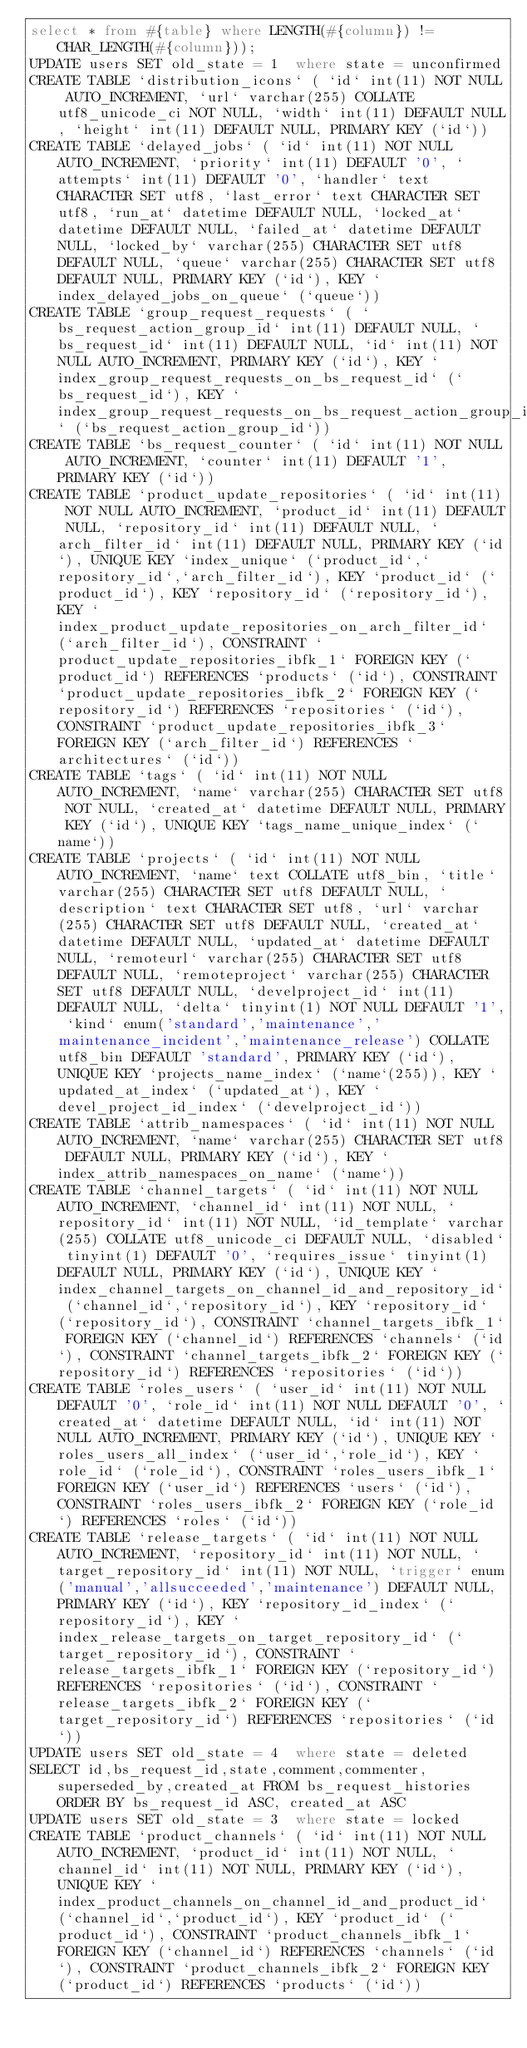Convert code to text. <code><loc_0><loc_0><loc_500><loc_500><_SQL_>select * from #{table} where LENGTH(#{column}) != CHAR_LENGTH(#{column}));
UPDATE users SET old_state = 1  where state = unconfirmed
CREATE TABLE `distribution_icons` ( `id` int(11) NOT NULL AUTO_INCREMENT, `url` varchar(255) COLLATE utf8_unicode_ci NOT NULL, `width` int(11) DEFAULT NULL, `height` int(11) DEFAULT NULL, PRIMARY KEY (`id`))
CREATE TABLE `delayed_jobs` ( `id` int(11) NOT NULL AUTO_INCREMENT, `priority` int(11) DEFAULT '0', `attempts` int(11) DEFAULT '0', `handler` text CHARACTER SET utf8, `last_error` text CHARACTER SET utf8, `run_at` datetime DEFAULT NULL, `locked_at` datetime DEFAULT NULL, `failed_at` datetime DEFAULT NULL, `locked_by` varchar(255) CHARACTER SET utf8 DEFAULT NULL, `queue` varchar(255) CHARACTER SET utf8 DEFAULT NULL, PRIMARY KEY (`id`), KEY `index_delayed_jobs_on_queue` (`queue`))
CREATE TABLE `group_request_requests` ( `bs_request_action_group_id` int(11) DEFAULT NULL, `bs_request_id` int(11) DEFAULT NULL, `id` int(11) NOT NULL AUTO_INCREMENT, PRIMARY KEY (`id`), KEY `index_group_request_requests_on_bs_request_id` (`bs_request_id`), KEY `index_group_request_requests_on_bs_request_action_group_id` (`bs_request_action_group_id`))
CREATE TABLE `bs_request_counter` ( `id` int(11) NOT NULL AUTO_INCREMENT, `counter` int(11) DEFAULT '1', PRIMARY KEY (`id`))
CREATE TABLE `product_update_repositories` ( `id` int(11) NOT NULL AUTO_INCREMENT, `product_id` int(11) DEFAULT NULL, `repository_id` int(11) DEFAULT NULL, `arch_filter_id` int(11) DEFAULT NULL, PRIMARY KEY (`id`), UNIQUE KEY `index_unique` (`product_id`,`repository_id`,`arch_filter_id`), KEY `product_id` (`product_id`), KEY `repository_id` (`repository_id`), KEY `index_product_update_repositories_on_arch_filter_id` (`arch_filter_id`), CONSTRAINT `product_update_repositories_ibfk_1` FOREIGN KEY (`product_id`) REFERENCES `products` (`id`), CONSTRAINT `product_update_repositories_ibfk_2` FOREIGN KEY (`repository_id`) REFERENCES `repositories` (`id`), CONSTRAINT `product_update_repositories_ibfk_3` FOREIGN KEY (`arch_filter_id`) REFERENCES `architectures` (`id`))
CREATE TABLE `tags` ( `id` int(11) NOT NULL AUTO_INCREMENT, `name` varchar(255) CHARACTER SET utf8 NOT NULL, `created_at` datetime DEFAULT NULL, PRIMARY KEY (`id`), UNIQUE KEY `tags_name_unique_index` (`name`))
CREATE TABLE `projects` ( `id` int(11) NOT NULL AUTO_INCREMENT, `name` text COLLATE utf8_bin, `title` varchar(255) CHARACTER SET utf8 DEFAULT NULL, `description` text CHARACTER SET utf8, `url` varchar(255) CHARACTER SET utf8 DEFAULT NULL, `created_at` datetime DEFAULT NULL, `updated_at` datetime DEFAULT NULL, `remoteurl` varchar(255) CHARACTER SET utf8 DEFAULT NULL, `remoteproject` varchar(255) CHARACTER SET utf8 DEFAULT NULL, `develproject_id` int(11) DEFAULT NULL, `delta` tinyint(1) NOT NULL DEFAULT '1', `kind` enum('standard','maintenance','maintenance_incident','maintenance_release') COLLATE utf8_bin DEFAULT 'standard', PRIMARY KEY (`id`), UNIQUE KEY `projects_name_index` (`name`(255)), KEY `updated_at_index` (`updated_at`), KEY `devel_project_id_index` (`develproject_id`))
CREATE TABLE `attrib_namespaces` ( `id` int(11) NOT NULL AUTO_INCREMENT, `name` varchar(255) CHARACTER SET utf8 DEFAULT NULL, PRIMARY KEY (`id`), KEY `index_attrib_namespaces_on_name` (`name`))
CREATE TABLE `channel_targets` ( `id` int(11) NOT NULL AUTO_INCREMENT, `channel_id` int(11) NOT NULL, `repository_id` int(11) NOT NULL, `id_template` varchar(255) COLLATE utf8_unicode_ci DEFAULT NULL, `disabled` tinyint(1) DEFAULT '0', `requires_issue` tinyint(1) DEFAULT NULL, PRIMARY KEY (`id`), UNIQUE KEY `index_channel_targets_on_channel_id_and_repository_id` (`channel_id`,`repository_id`), KEY `repository_id` (`repository_id`), CONSTRAINT `channel_targets_ibfk_1` FOREIGN KEY (`channel_id`) REFERENCES `channels` (`id`), CONSTRAINT `channel_targets_ibfk_2` FOREIGN KEY (`repository_id`) REFERENCES `repositories` (`id`))
CREATE TABLE `roles_users` ( `user_id` int(11) NOT NULL DEFAULT '0', `role_id` int(11) NOT NULL DEFAULT '0', `created_at` datetime DEFAULT NULL, `id` int(11) NOT NULL AUTO_INCREMENT, PRIMARY KEY (`id`), UNIQUE KEY `roles_users_all_index` (`user_id`,`role_id`), KEY `role_id` (`role_id`), CONSTRAINT `roles_users_ibfk_1` FOREIGN KEY (`user_id`) REFERENCES `users` (`id`), CONSTRAINT `roles_users_ibfk_2` FOREIGN KEY (`role_id`) REFERENCES `roles` (`id`))
CREATE TABLE `release_targets` ( `id` int(11) NOT NULL AUTO_INCREMENT, `repository_id` int(11) NOT NULL, `target_repository_id` int(11) NOT NULL, `trigger` enum('manual','allsucceeded','maintenance') DEFAULT NULL, PRIMARY KEY (`id`), KEY `repository_id_index` (`repository_id`), KEY `index_release_targets_on_target_repository_id` (`target_repository_id`), CONSTRAINT `release_targets_ibfk_1` FOREIGN KEY (`repository_id`) REFERENCES `repositories` (`id`), CONSTRAINT `release_targets_ibfk_2` FOREIGN KEY (`target_repository_id`) REFERENCES `repositories` (`id`))
UPDATE users SET old_state = 4  where state = deleted
SELECT id,bs_request_id,state,comment,commenter,superseded_by,created_at FROM bs_request_histories ORDER BY bs_request_id ASC, created_at ASC
UPDATE users SET old_state = 3  where state = locked
CREATE TABLE `product_channels` ( `id` int(11) NOT NULL AUTO_INCREMENT, `product_id` int(11) NOT NULL, `channel_id` int(11) NOT NULL, PRIMARY KEY (`id`), UNIQUE KEY `index_product_channels_on_channel_id_and_product_id` (`channel_id`,`product_id`), KEY `product_id` (`product_id`), CONSTRAINT `product_channels_ibfk_1` FOREIGN KEY (`channel_id`) REFERENCES `channels` (`id`), CONSTRAINT `product_channels_ibfk_2` FOREIGN KEY (`product_id`) REFERENCES `products` (`id`))</code> 